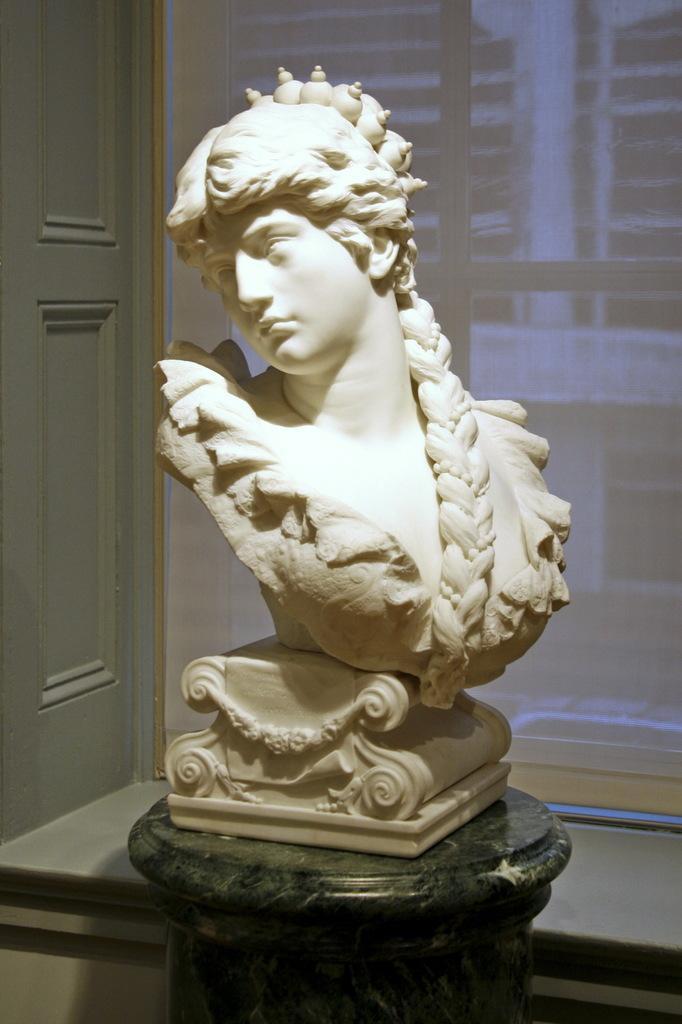Please provide a concise description of this image. In this picture I can see there is a statue here kept on the table and in there is a door and a window with a curtain. 